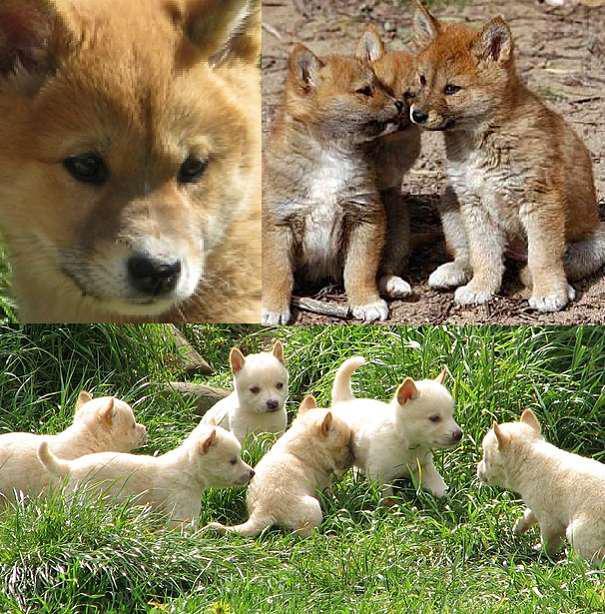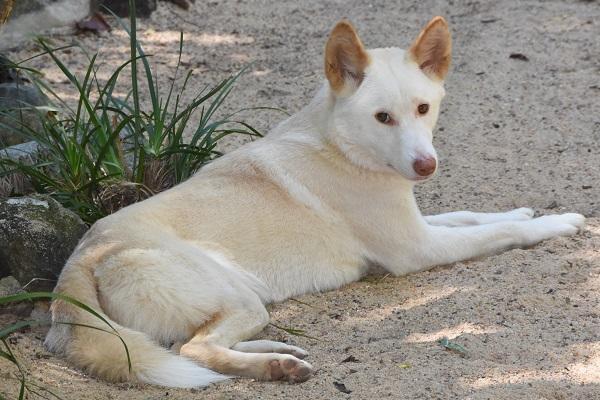The first image is the image on the left, the second image is the image on the right. For the images displayed, is the sentence "Each image includes canine pups, and at least one image also includes at least one adult dog." factually correct? Answer yes or no. No. 